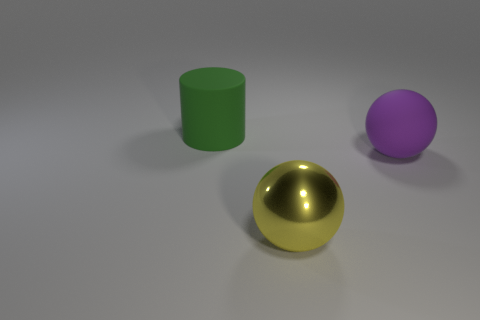Is there a large purple thing that has the same material as the cylinder? Yes, there is a large purple sphere in the image that appears to have a matte finish similar to the green cylinder's surface. 